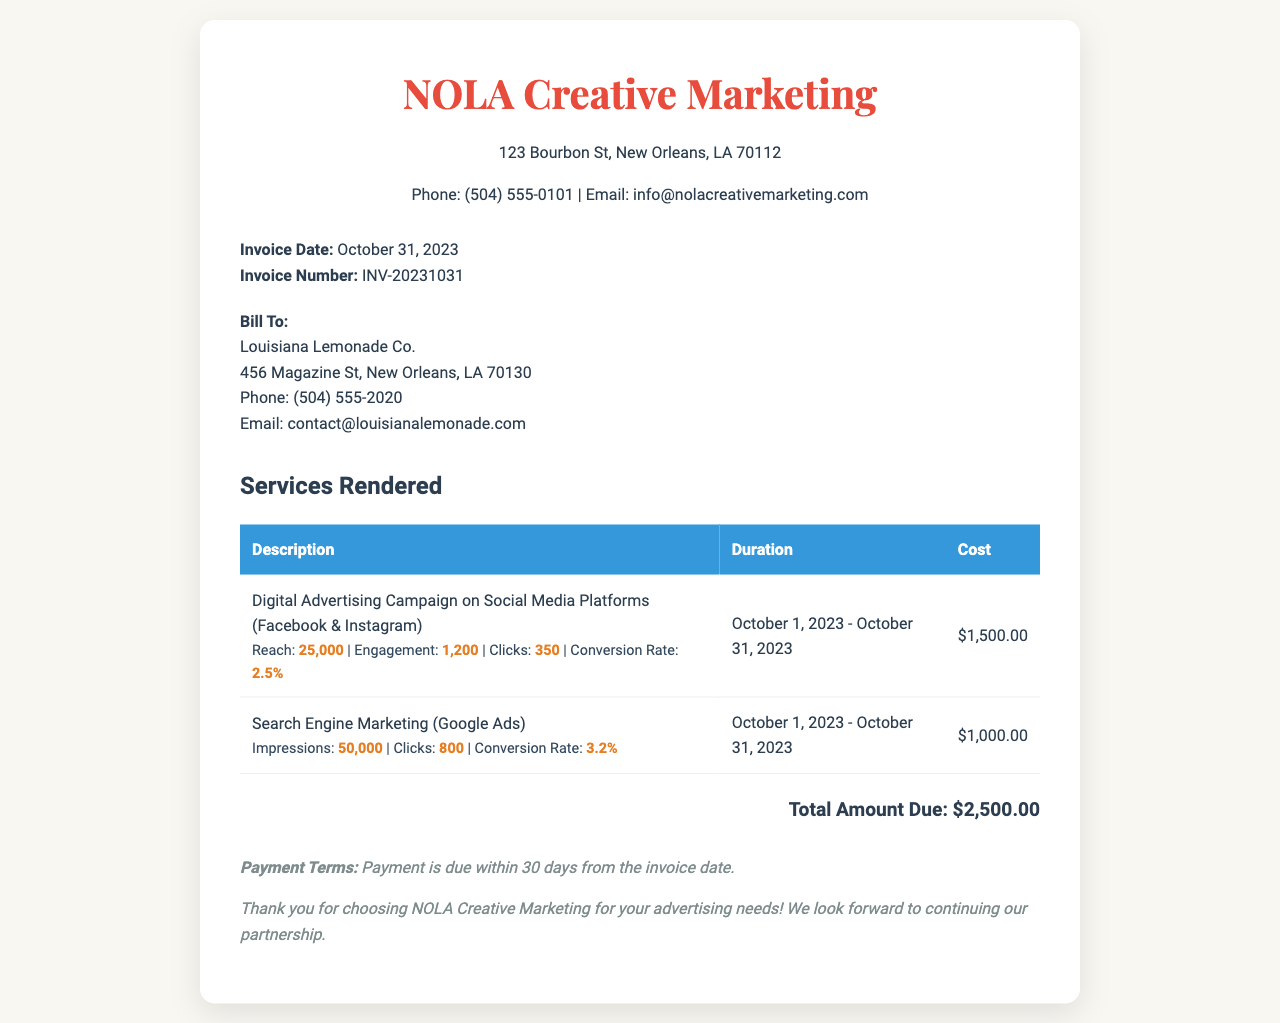What is the invoice number? The invoice number is a unique identifier for this document, found in the business details.
Answer: INV-20231031 Who is the invoice billed to? The "Bill To" section specifies the recipient of the invoice.
Answer: Louisiana Lemonade Co What is the reach of the social media campaign? The reach is specified under the metrics for the digital advertising campaign.
Answer: 25,000 What is the total amount due? The total amount due is located in the total section of the invoice.
Answer: $2,500.00 What was the duration of the search engine marketing? The duration is specified for each service rendered in the invoice.
Answer: October 1, 2023 - October 31, 2023 What is the conversion rate for the Google Ads campaign? The conversion rate for the Google Ads campaign is listed in its respective metrics.
Answer: 3.2% How many clicks were achieved in the digital advertising campaign? The number of clicks is given in the metrics section for the social media campaign.
Answer: 350 What is the payment term specified in the document? The payment term is stated towards the end of the invoice in the notes section.
Answer: Payment is due within 30 days from the invoice date What service had the highest cost? The costs of each service are listed in the services section, allowing for comparison.
Answer: Digital Advertising Campaign on Social Media Platforms 